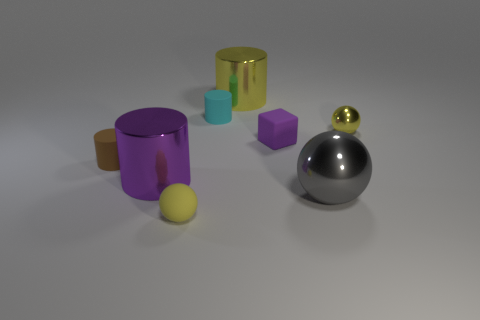There is a large thing that is the same color as the small metal object; what is it made of?
Your response must be concise. Metal. Are there any other things that are the same shape as the tiny purple thing?
Provide a short and direct response. No. There is a small object that is behind the yellow metal ball in front of the large yellow thing behind the purple cylinder; what color is it?
Give a very brief answer. Cyan. There is a tiny cyan thing; does it have the same shape as the small yellow thing behind the big purple cylinder?
Provide a short and direct response. No. There is a metallic object that is on the right side of the small purple block and in front of the brown object; what is its color?
Keep it short and to the point. Gray. Is there a small metallic object that has the same shape as the big gray thing?
Your answer should be compact. Yes. Is the color of the tiny metallic sphere the same as the matte sphere?
Your answer should be very brief. Yes. Are there any large cylinders that are right of the rubber cylinder behind the tiny brown matte thing?
Ensure brevity in your answer.  Yes. What number of things are either small spheres to the left of the tiny purple matte object or small matte objects behind the large purple cylinder?
Your response must be concise. 4. How many things are purple things or big metal things right of the purple metallic cylinder?
Your response must be concise. 4. 